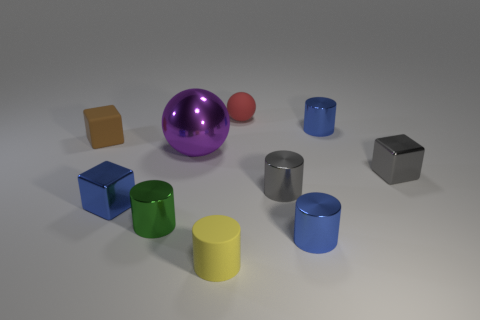Can you describe the lighting and shadows in the scene? The lighting in the scene appears to be neutral and diffused, providing a soft illumination without harsh shadows. It seems to be coming from above, as indicated by the gentle shadows beneath and to the sides of the objects, which add depth and dimension to the image. 